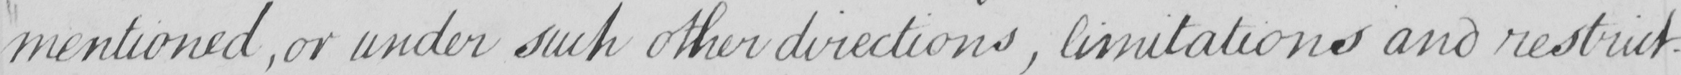What text is written in this handwritten line? mentioned , or under such other directions , limitations and restrict- 